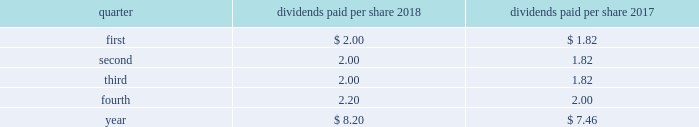Part ii item 5 .
Market for registrant 2019s common equity , related stockholder matters and issuer purchases of equity securities at january 25 , 2019 , we had 26812 holders of record of our common stock , par value $ 1 per share .
Our common stock is traded on the new york stock exchange ( nyse ) under the symbol lmt .
Information concerning dividends paid on lockheed martin common stock during the past two years is as follows : common stock - dividends paid per share .
Stockholder return performance graph the following graph compares the total return on a cumulative basis of $ 100 invested in lockheed martin common stock on december 31 , 2013 to the standard and poor 2019s ( s&p ) 500 index and the s&p aerospace & defense index .
The s&p aerospace & defense index comprises arconic inc. , general dynamics corporation , harris corporation , huntington ingalls industries , l3 technologies , inc. , lockheed martin corporation , northrop grumman corporation , raytheon company , textron inc. , the boeing company , transdigm group inc. , and united technologies corporation .
The stockholder return performance indicated on the graph is not a guarantee of future performance. .
What was the percentage increase in the dividends paid per share for the year from 2007 to 2008? 
Computations: ((8.20 - 7.46) / 7.46)
Answer: 0.0992. 